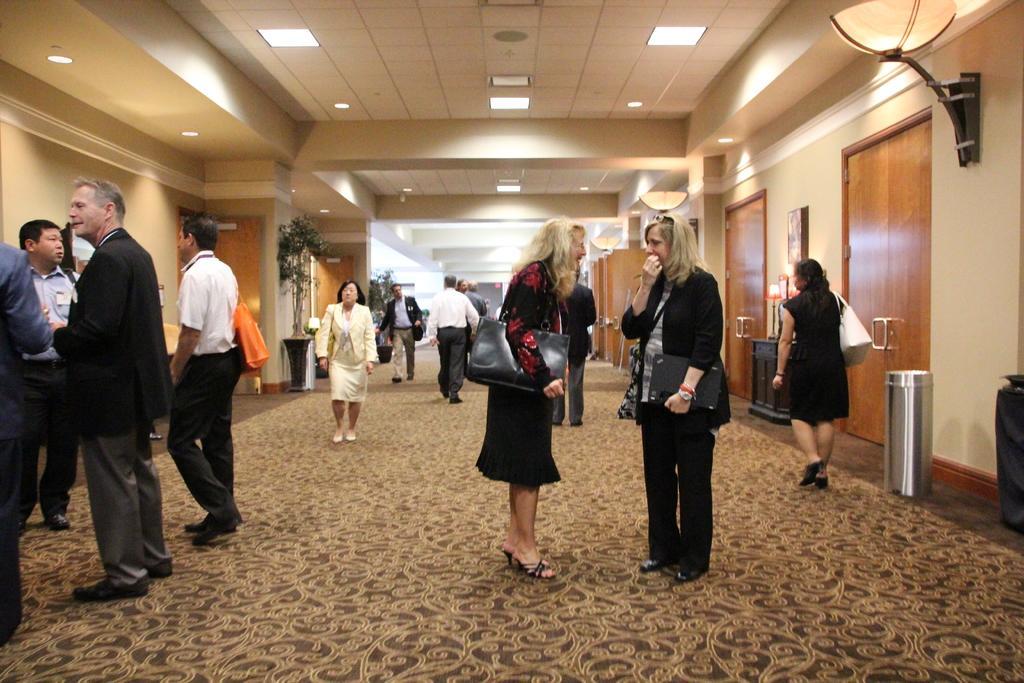Describe this image in one or two sentences. There are people standing on the floor as we can see in the middle of this image. There are doors and a wall in the background. We can see lights arranged at the top of this image. There is a dustbin on the right side of this image. 